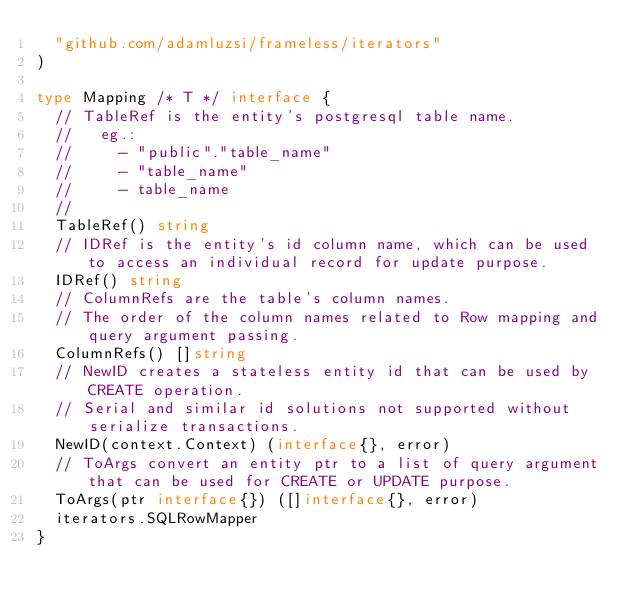<code> <loc_0><loc_0><loc_500><loc_500><_Go_>	"github.com/adamluzsi/frameless/iterators"
)

type Mapping /* T */ interface {
	// TableRef is the entity's postgresql table name.
	//   eg.:
	//     - "public"."table_name"
	//     - "table_name"
	//     - table_name
	//
	TableRef() string
	// IDRef is the entity's id column name, which can be used to access an individual record for update purpose.
	IDRef() string
	// ColumnRefs are the table's column names.
	// The order of the column names related to Row mapping and query argument passing.
	ColumnRefs() []string
	// NewID creates a stateless entity id that can be used by CREATE operation.
	// Serial and similar id solutions not supported without serialize transactions.
	NewID(context.Context) (interface{}, error)
	// ToArgs convert an entity ptr to a list of query argument that can be used for CREATE or UPDATE purpose.
	ToArgs(ptr interface{}) ([]interface{}, error)
	iterators.SQLRowMapper
}
</code> 